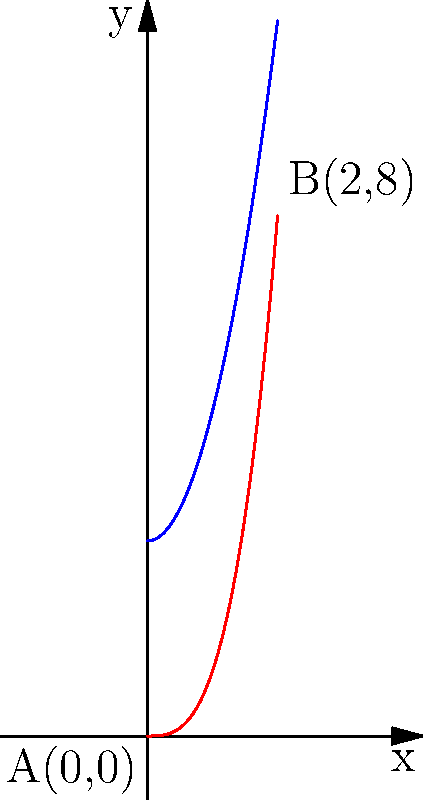A particle moves along the curve $C: y = x^3$ from point $A(0,0)$ to point $B(2,8)$ in a force field given by $\mathbf{F}(x,y) = (2x^2 + 3)\mathbf{i} + 2xy\mathbf{j}$. Calculate the work done by the force field on the particle along this path using a line integral. To solve this problem, we'll follow these steps:

1) The work done is given by the line integral:
   $$W = \int_C \mathbf{F} \cdot d\mathbf{r}$$

2) We need to parameterize the curve $C: y = x^3$. We can use $x$ as our parameter:
   $x = t$, $y = t^3$, where $0 \leq t \leq 2$

3) Now, $d\mathbf{r} = dx\mathbf{i} + dy\mathbf{j} = dt\mathbf{i} + 3t^2dt\mathbf{j}$

4) Substituting the force field and $d\mathbf{r}$:
   $$W = \int_0^2 [(2t^2 + 3) \cdot 1 + 2t(t^3) \cdot 3t^2] dt$$

5) Simplifying:
   $$W = \int_0^2 (2t^2 + 3 + 6t^6) dt$$

6) Integrating:
   $$W = [\frac{2t^3}{3} + 3t + \frac{6t^7}{7}]_0^2$$

7) Evaluating the limits:
   $$W = (\frac{16}{3} + 6 + \frac{768}{7}) - (0 + 0 + 0)$$

8) Simplifying:
   $$W = \frac{16}{3} + 6 + \frac{768}{7} = \frac{1792}{21}$$

Therefore, the work done by the force field on the particle is $\frac{1792}{21}$ units.
Answer: $\frac{1792}{21}$ units 